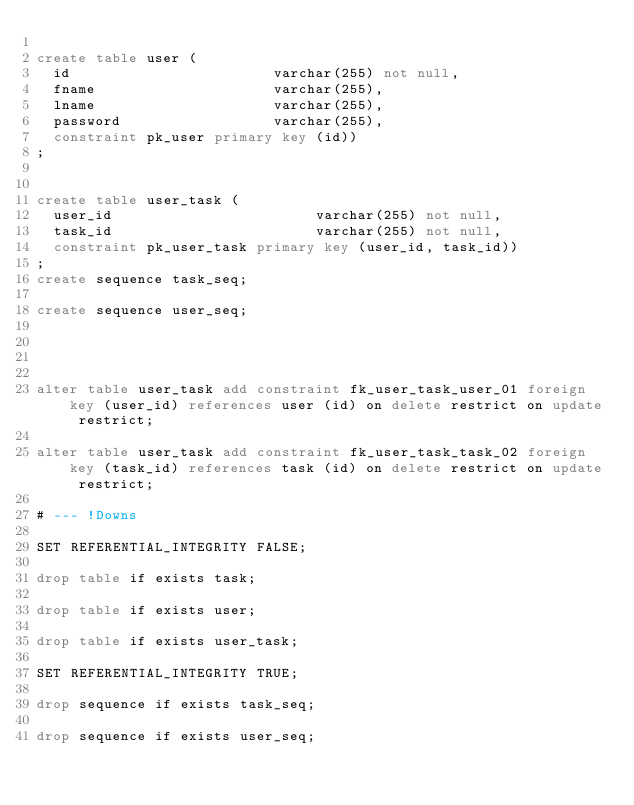<code> <loc_0><loc_0><loc_500><loc_500><_SQL_>
create table user (
  id                        varchar(255) not null,
  fname                     varchar(255),
  lname                     varchar(255),
  password                  varchar(255),
  constraint pk_user primary key (id))
;


create table user_task (
  user_id                        varchar(255) not null,
  task_id                        varchar(255) not null,
  constraint pk_user_task primary key (user_id, task_id))
;
create sequence task_seq;

create sequence user_seq;




alter table user_task add constraint fk_user_task_user_01 foreign key (user_id) references user (id) on delete restrict on update restrict;

alter table user_task add constraint fk_user_task_task_02 foreign key (task_id) references task (id) on delete restrict on update restrict;

# --- !Downs

SET REFERENTIAL_INTEGRITY FALSE;

drop table if exists task;

drop table if exists user;

drop table if exists user_task;

SET REFERENTIAL_INTEGRITY TRUE;

drop sequence if exists task_seq;

drop sequence if exists user_seq;

</code> 